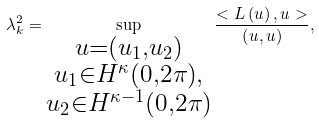Convert formula to latex. <formula><loc_0><loc_0><loc_500><loc_500>\lambda _ { k } ^ { 2 } = \sup _ { \substack { u = \left ( u _ { 1 } , u _ { 2 } \right ) \\ u _ { 1 } \in H ^ { \kappa } \left ( 0 , 2 \pi \right ) , \\ u _ { 2 } \in H ^ { \kappa - 1 } \left ( 0 , 2 \pi \right ) } } \frac { < L \left ( u \right ) , u > } { \left ( u , u \right ) } ,</formula> 